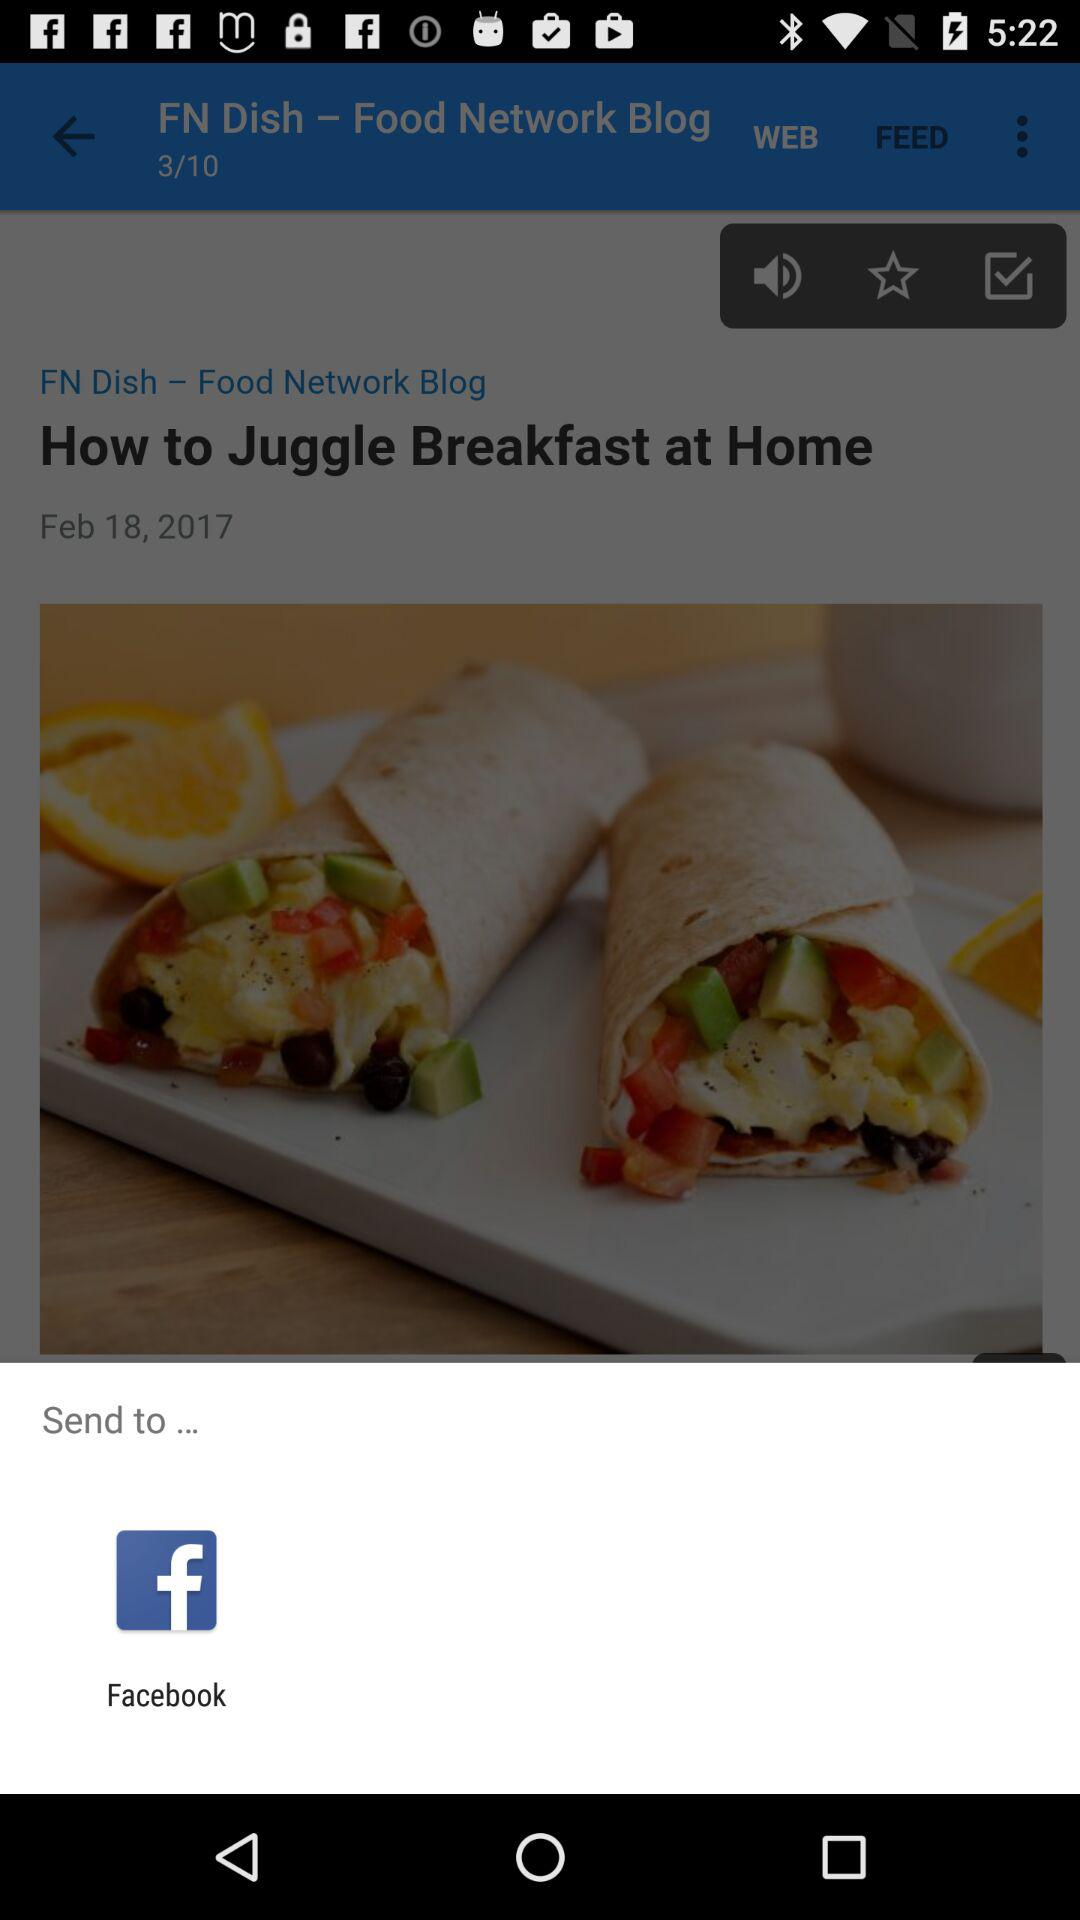What is the title of the post? The title of the post is "How to Juggle Breakfast at Home". 